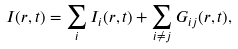Convert formula to latex. <formula><loc_0><loc_0><loc_500><loc_500>I ( { r } , t ) = \sum _ { i } I _ { i } ( { r } , t ) + \sum _ { i \neq j } G _ { i j } ( { r } , t ) ,</formula> 